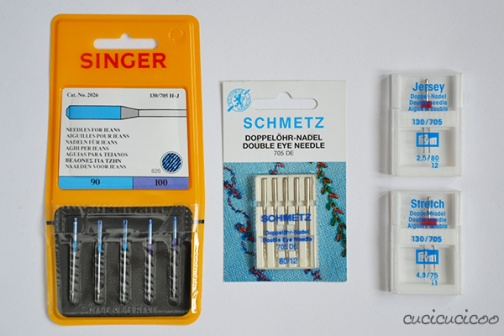What are the benefits of using specialized needles like those displayed for different fabric types? Using specialized needles is crucial for achieving optimal results in sewing projects because they are designed to complement the properties of different fabrics. For instance, needles for knit fabrics, like those in the Singer package, are designed to prevent damage by sliding between fabric yarns rather than piercing them. Similarly, stretch needles have a slightly rounded tip and special eye design that helps manage the elasticity of the fabric, preventing skipped stitches and fabric puckering. How frequently should these needles be replaced? Needles should generally be replaced after every project or every 8 hours of sewing, whichever comes first. Over time, needles can become dull or bent, which can lead to stitch inconsistencies, fabric damage, or even damage to the sewing machine itself. 